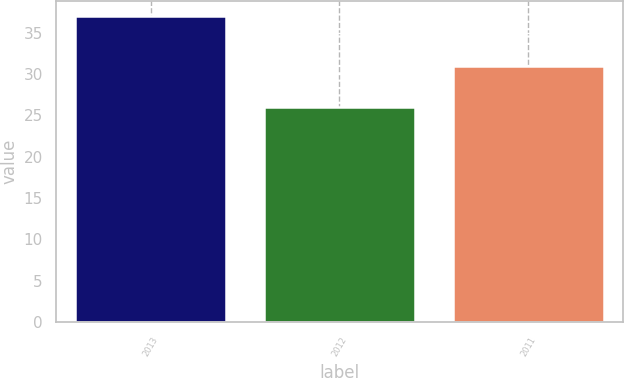Convert chart to OTSL. <chart><loc_0><loc_0><loc_500><loc_500><bar_chart><fcel>2013<fcel>2012<fcel>2011<nl><fcel>37<fcel>26<fcel>31<nl></chart> 